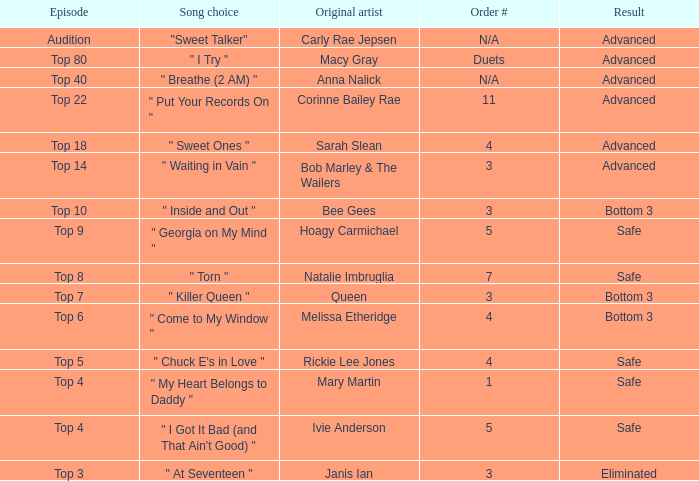Which one of the songs was originally performed by Rickie Lee Jones? " Chuck E's in Love ". 